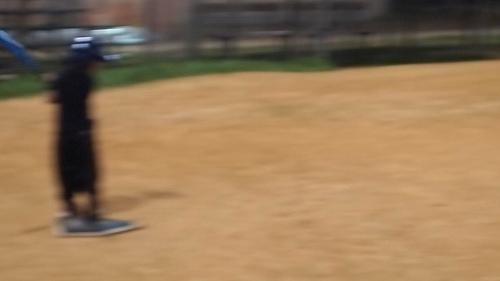Question: where was this photo taken?
Choices:
A. On a basketball court.
B. On a baseball field.
C. On a soccer field.
D. On a beach.
Answer with the letter. Answer: B Question: who is featured in this photo?
Choices:
A. Boy.
B. A child.
C. Girl.
D. Man.
Answer with the letter. Answer: B Question: what color are the child's clothes?
Choices:
A. Black.
B. Red.
C. Blue.
D. Grey.
Answer with the letter. Answer: A 